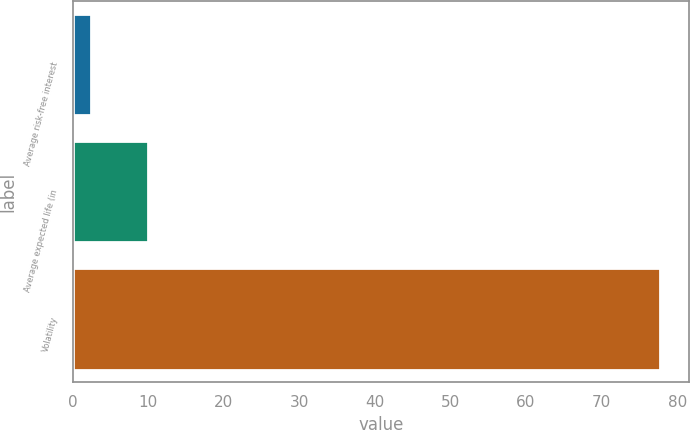<chart> <loc_0><loc_0><loc_500><loc_500><bar_chart><fcel>Average risk-free interest<fcel>Average expected life (in<fcel>Volatility<nl><fcel>2.5<fcel>10.02<fcel>77.7<nl></chart> 